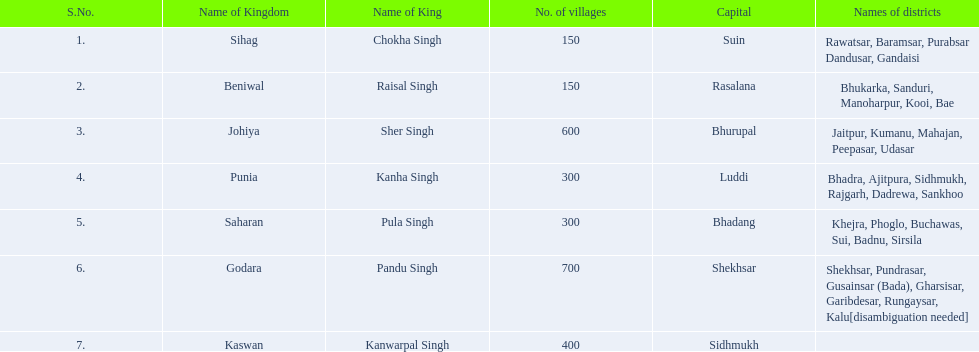What kingdom has the largest number of villages? 700. Which kingdom ranks second in terms of the number of villages? 600. Which specific kingdom is home to 600 villages? Johiya. 